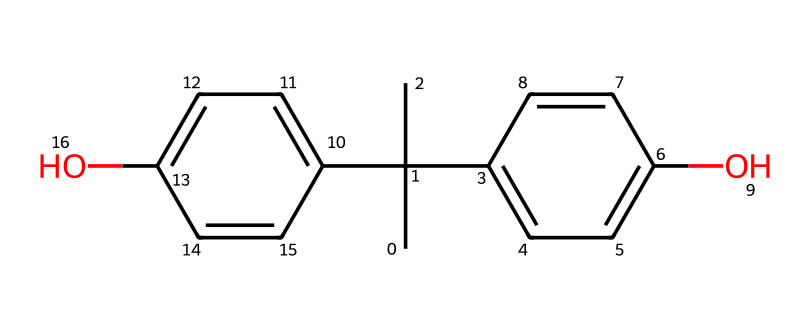What is the total number of carbon atoms in this chemical? Counting the carbon atoms in the provided SMILES representation indicates that there are two tert-butyl groups (CC(C)(C)), a phenol substitution with two aromatic rings (C1 and C2), contributing to the carbon count. Altogether, there are 15 carbon atoms in the entire structure.
Answer: 15 How many hydroxyl (–OH) groups are present in this compound? The presence of two hydroxyl groups can be identified by looking for ‘O’ followed by H in the structure. In the provided SMILES, there are two phenolic units, each having one –OH group, resulting in a total of two hydroxyl groups.
Answer: 2 Is this chemical likely to be a solid, liquid, or gas at room temperature? The presence of multiple aromatic rings and hydroxyl groups suggests that the molecule has a relatively high molecular weight and strong intermolecular forces, leading to a solid state at room temperature.
Answer: solid What type of chemical bonding is primarily present in this molecule? The chemical structure is composed mainly of covalent bonds, which are formed between the carbon, oxygen, and hydrogen atoms. The presence of aromatic rings further indicates that delocalized electrons contribute to the stability of the covalent bonding.
Answer: covalent What distinguishes bisphenol A from other phenols in terms of its structure? Bisphenol A can be characterized by its unique structure that includes two hydroxyl groups attached to separate aromatic rings rather than a single phenolic group. In addition, it has tert-butyl groups that increase steric hindrance, setting it apart from simpler phenols.
Answer: two aromatic rings 